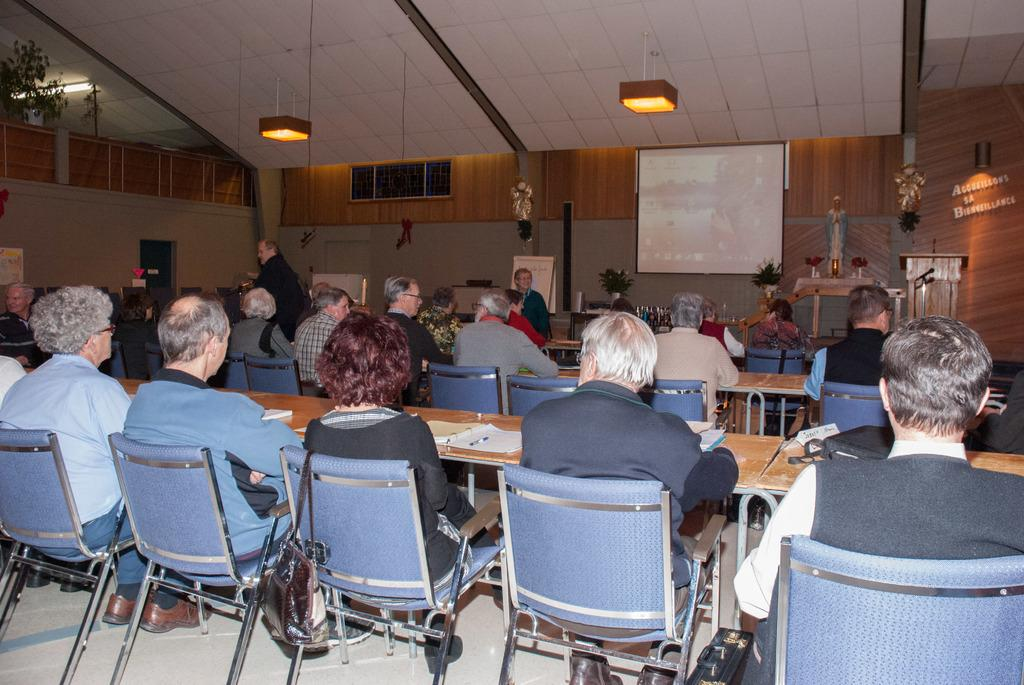How many people are in the image? There is a group of people in the image. What are the people doing in the image? The people are sitting on chairs. Where are the chairs located in relation to the table? The chairs are in front of a table. What can be seen on the wall in the image? There is a projector on the wall in the image. How many kittens are playing with the clock in the image? There are no kittens or clocks present in the image. What type of trade is being conducted in the image? There is no indication of any trade being conducted in the image. 